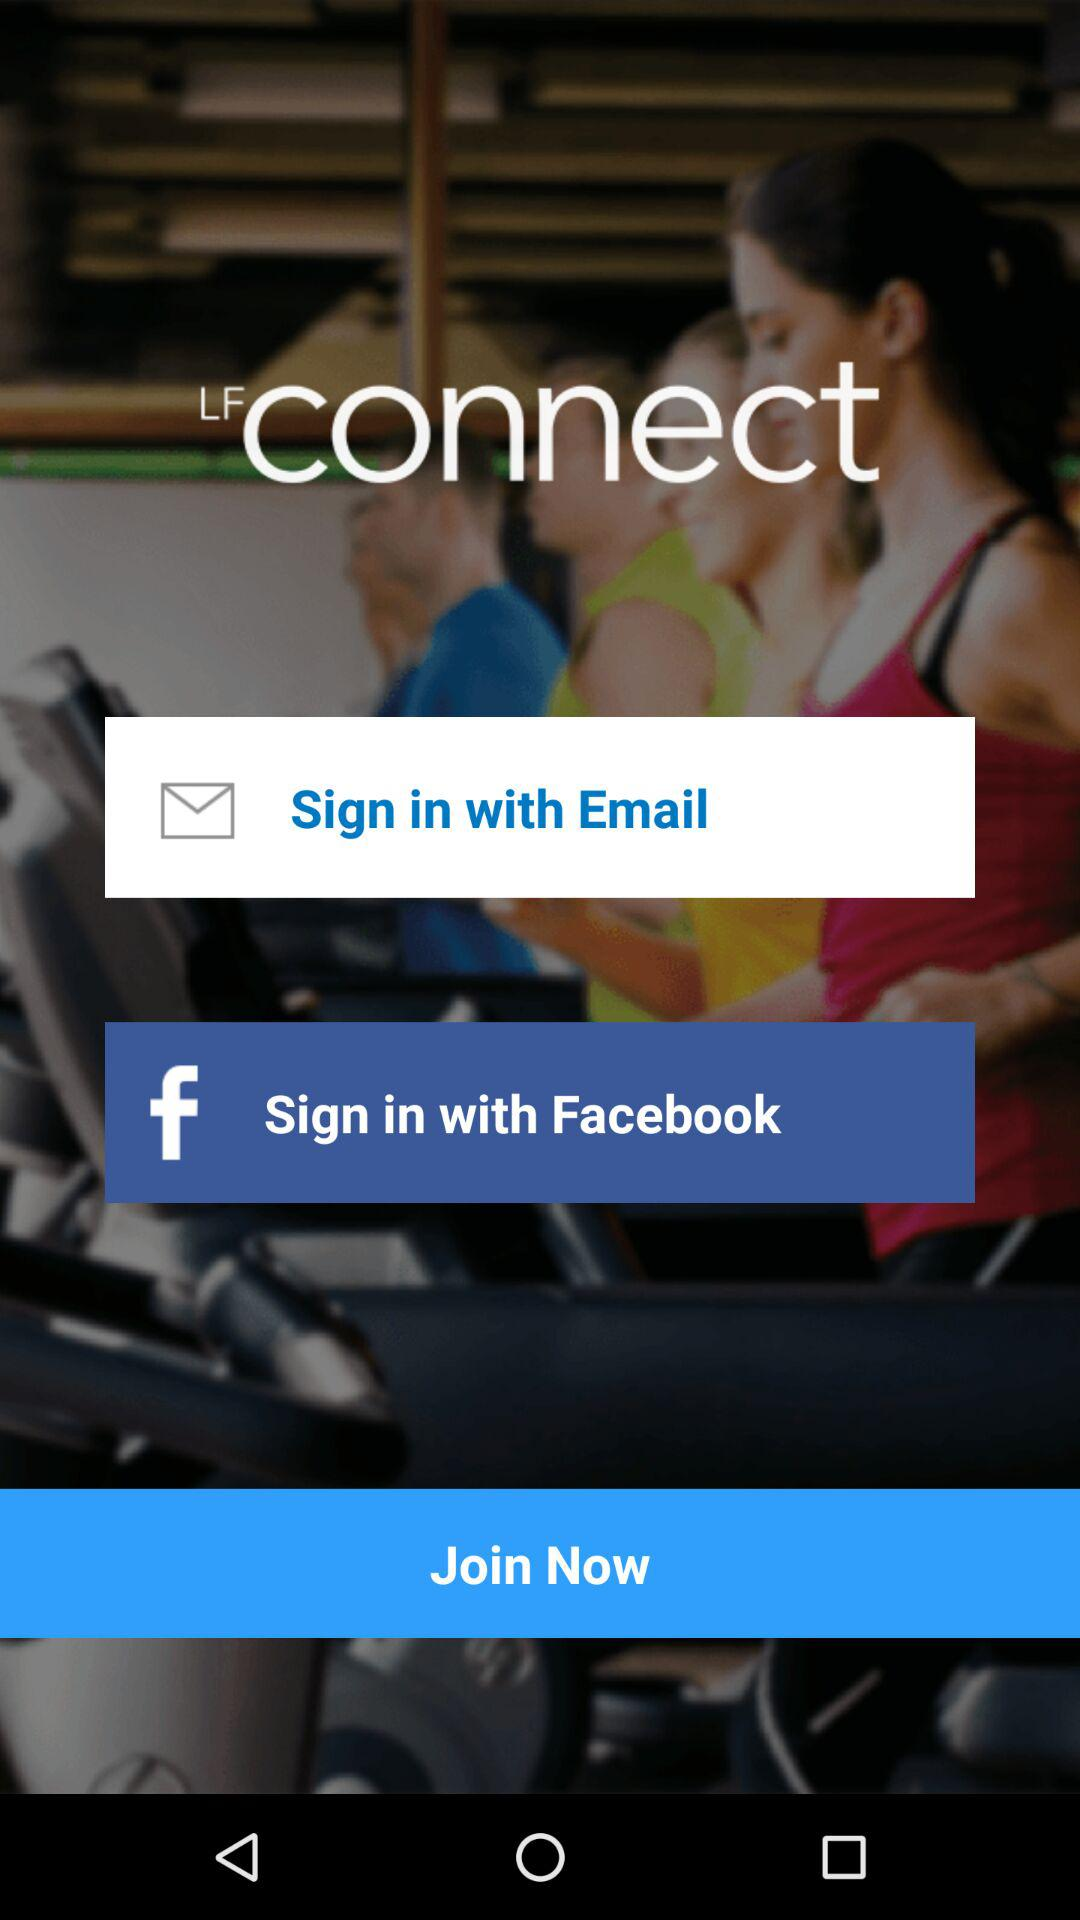Which email address is used to sign in to the account?
When the provided information is insufficient, respond with <no answer>. <no answer> 